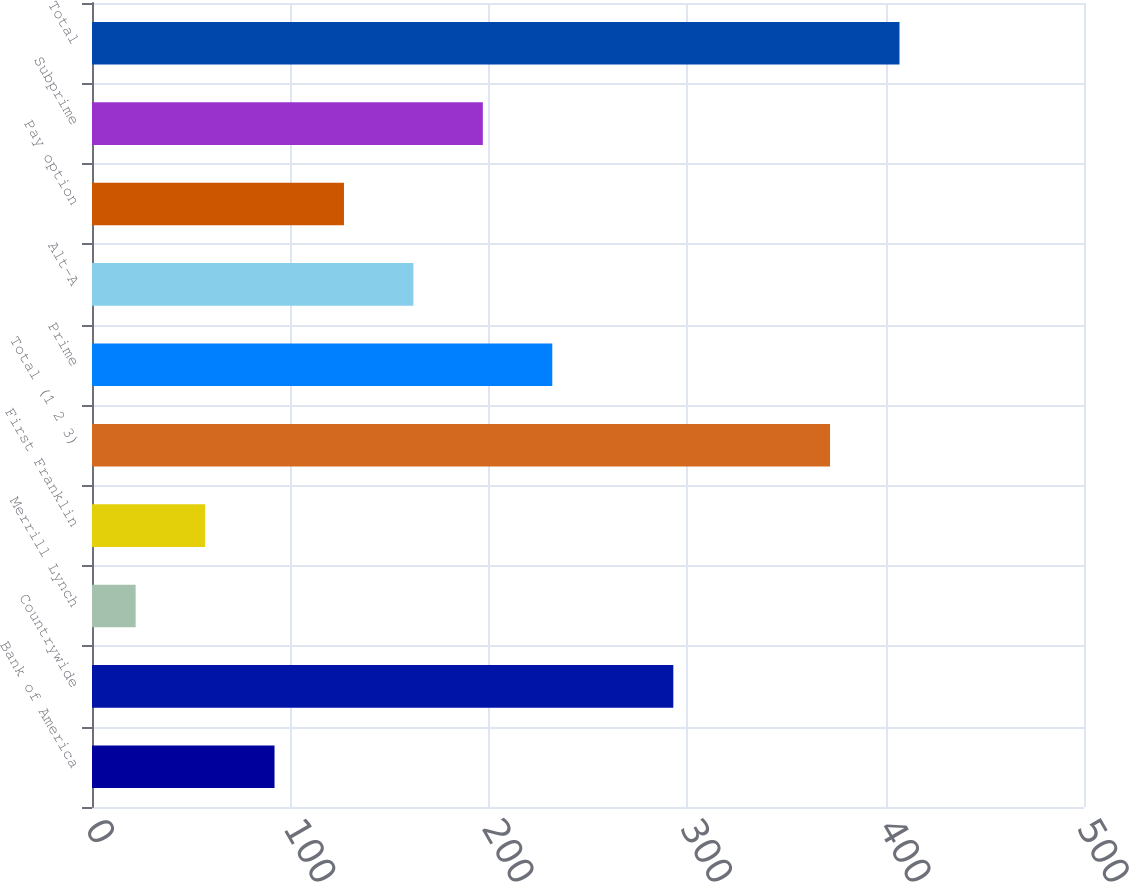Convert chart. <chart><loc_0><loc_0><loc_500><loc_500><bar_chart><fcel>Bank of America<fcel>Countrywide<fcel>Merrill Lynch<fcel>First Franklin<fcel>Total (1 2 3)<fcel>Prime<fcel>Alt-A<fcel>Pay option<fcel>Subprime<fcel>Total<nl><fcel>92<fcel>293<fcel>22<fcel>57<fcel>372<fcel>232<fcel>162<fcel>127<fcel>197<fcel>407<nl></chart> 